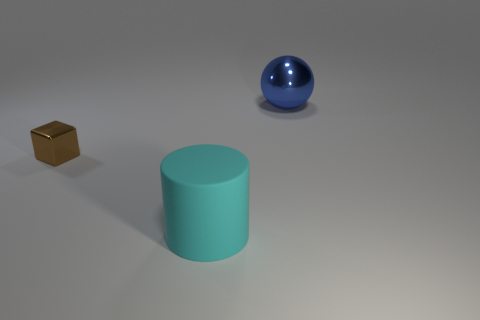Can you describe the colors and shapes of the objects in the image? Certainly! In the image, there are three objects: a small brown cube with a metallic finish, a teal cylindrical object with a matte surface, and a shiny blue sphere. The cube has sharp edges and defined corners, the cylinder has a flat top and smooth circular sides, and the sphere is completely round with a smooth surface that reflects the light. 